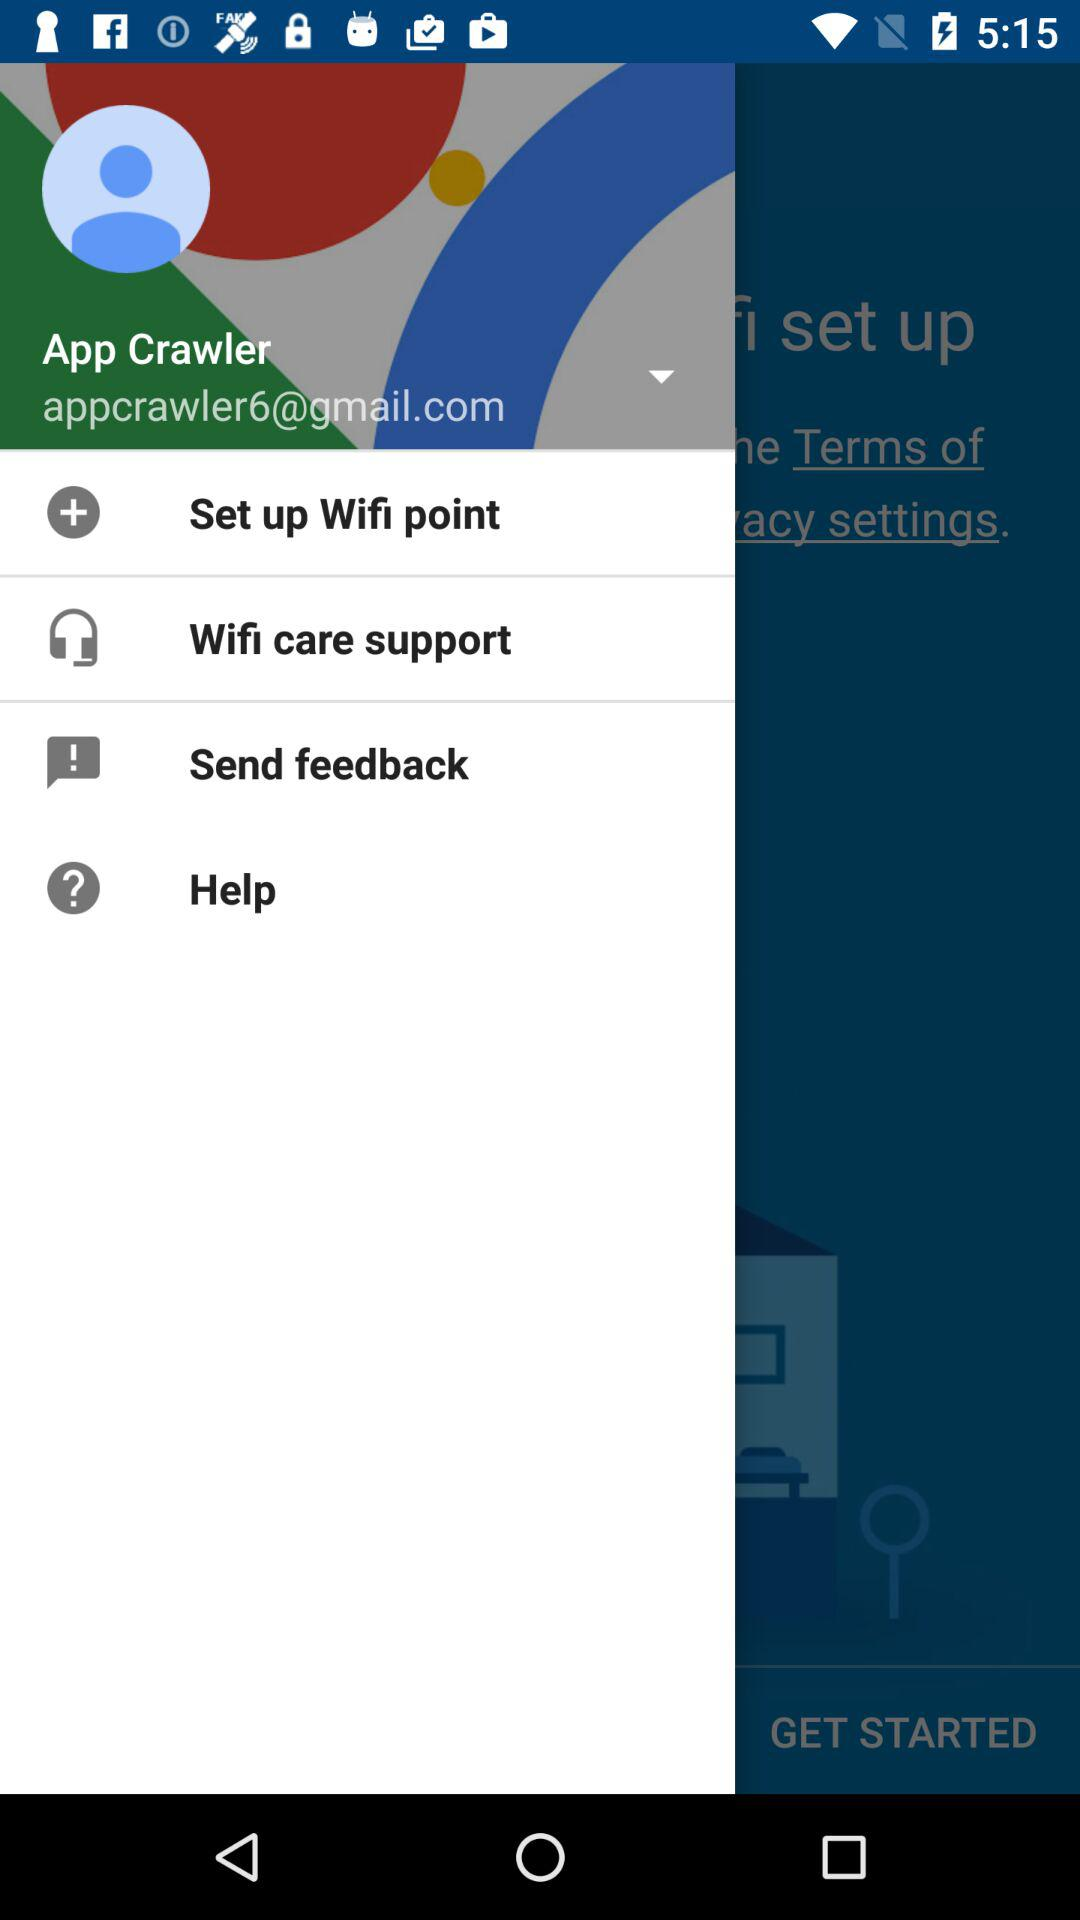What is the user's name? The user's name is App Crawler. 